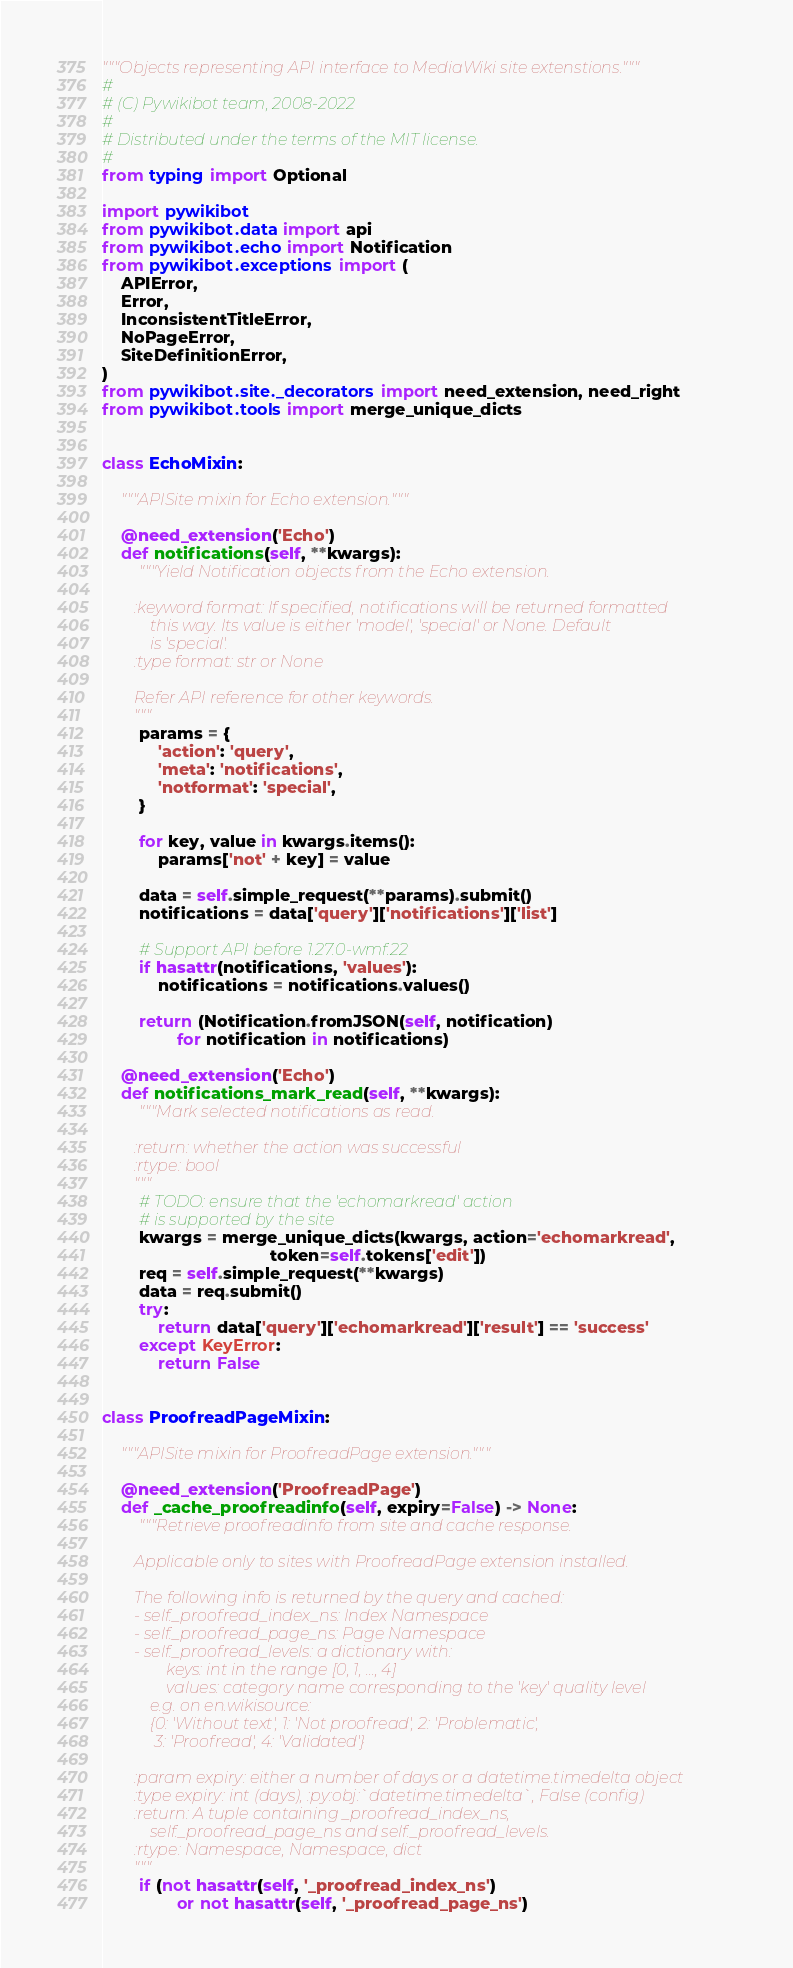Convert code to text. <code><loc_0><loc_0><loc_500><loc_500><_Python_>"""Objects representing API interface to MediaWiki site extenstions."""
#
# (C) Pywikibot team, 2008-2022
#
# Distributed under the terms of the MIT license.
#
from typing import Optional

import pywikibot
from pywikibot.data import api
from pywikibot.echo import Notification
from pywikibot.exceptions import (
    APIError,
    Error,
    InconsistentTitleError,
    NoPageError,
    SiteDefinitionError,
)
from pywikibot.site._decorators import need_extension, need_right
from pywikibot.tools import merge_unique_dicts


class EchoMixin:

    """APISite mixin for Echo extension."""

    @need_extension('Echo')
    def notifications(self, **kwargs):
        """Yield Notification objects from the Echo extension.

        :keyword format: If specified, notifications will be returned formatted
            this way. Its value is either 'model', 'special' or None. Default
            is 'special'.
        :type format: str or None

        Refer API reference for other keywords.
        """
        params = {
            'action': 'query',
            'meta': 'notifications',
            'notformat': 'special',
        }

        for key, value in kwargs.items():
            params['not' + key] = value

        data = self.simple_request(**params).submit()
        notifications = data['query']['notifications']['list']

        # Support API before 1.27.0-wmf.22
        if hasattr(notifications, 'values'):
            notifications = notifications.values()

        return (Notification.fromJSON(self, notification)
                for notification in notifications)

    @need_extension('Echo')
    def notifications_mark_read(self, **kwargs):
        """Mark selected notifications as read.

        :return: whether the action was successful
        :rtype: bool
        """
        # TODO: ensure that the 'echomarkread' action
        # is supported by the site
        kwargs = merge_unique_dicts(kwargs, action='echomarkread',
                                    token=self.tokens['edit'])
        req = self.simple_request(**kwargs)
        data = req.submit()
        try:
            return data['query']['echomarkread']['result'] == 'success'
        except KeyError:
            return False


class ProofreadPageMixin:

    """APISite mixin for ProofreadPage extension."""

    @need_extension('ProofreadPage')
    def _cache_proofreadinfo(self, expiry=False) -> None:
        """Retrieve proofreadinfo from site and cache response.

        Applicable only to sites with ProofreadPage extension installed.

        The following info is returned by the query and cached:
        - self._proofread_index_ns: Index Namespace
        - self._proofread_page_ns: Page Namespace
        - self._proofread_levels: a dictionary with:
                keys: int in the range [0, 1, ..., 4]
                values: category name corresponding to the 'key' quality level
            e.g. on en.wikisource:
            {0: 'Without text', 1: 'Not proofread', 2: 'Problematic',
             3: 'Proofread', 4: 'Validated'}

        :param expiry: either a number of days or a datetime.timedelta object
        :type expiry: int (days), :py:obj:`datetime.timedelta`, False (config)
        :return: A tuple containing _proofread_index_ns,
            self._proofread_page_ns and self._proofread_levels.
        :rtype: Namespace, Namespace, dict
        """
        if (not hasattr(self, '_proofread_index_ns')
                or not hasattr(self, '_proofread_page_ns')</code> 